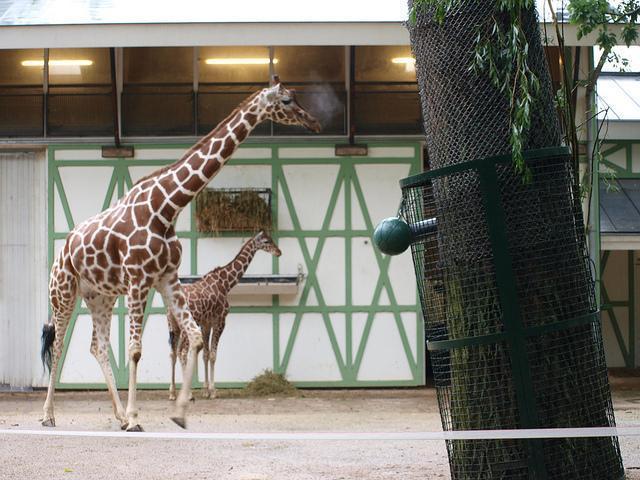How many giraffes?
Give a very brief answer. 2. How many giraffes are in the picture?
Give a very brief answer. 2. 